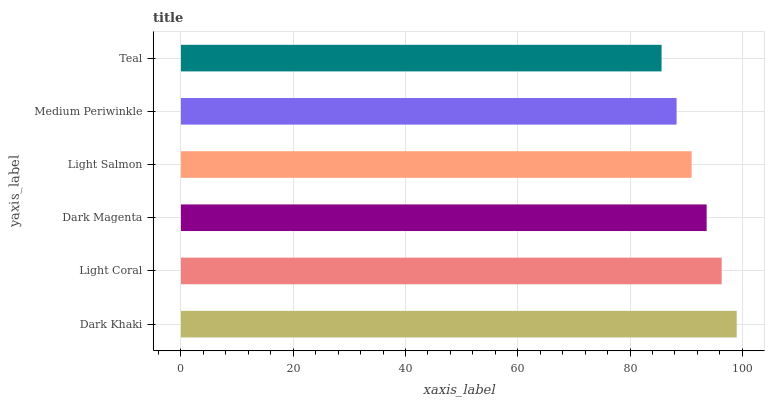Is Teal the minimum?
Answer yes or no. Yes. Is Dark Khaki the maximum?
Answer yes or no. Yes. Is Light Coral the minimum?
Answer yes or no. No. Is Light Coral the maximum?
Answer yes or no. No. Is Dark Khaki greater than Light Coral?
Answer yes or no. Yes. Is Light Coral less than Dark Khaki?
Answer yes or no. Yes. Is Light Coral greater than Dark Khaki?
Answer yes or no. No. Is Dark Khaki less than Light Coral?
Answer yes or no. No. Is Dark Magenta the high median?
Answer yes or no. Yes. Is Light Salmon the low median?
Answer yes or no. Yes. Is Teal the high median?
Answer yes or no. No. Is Teal the low median?
Answer yes or no. No. 